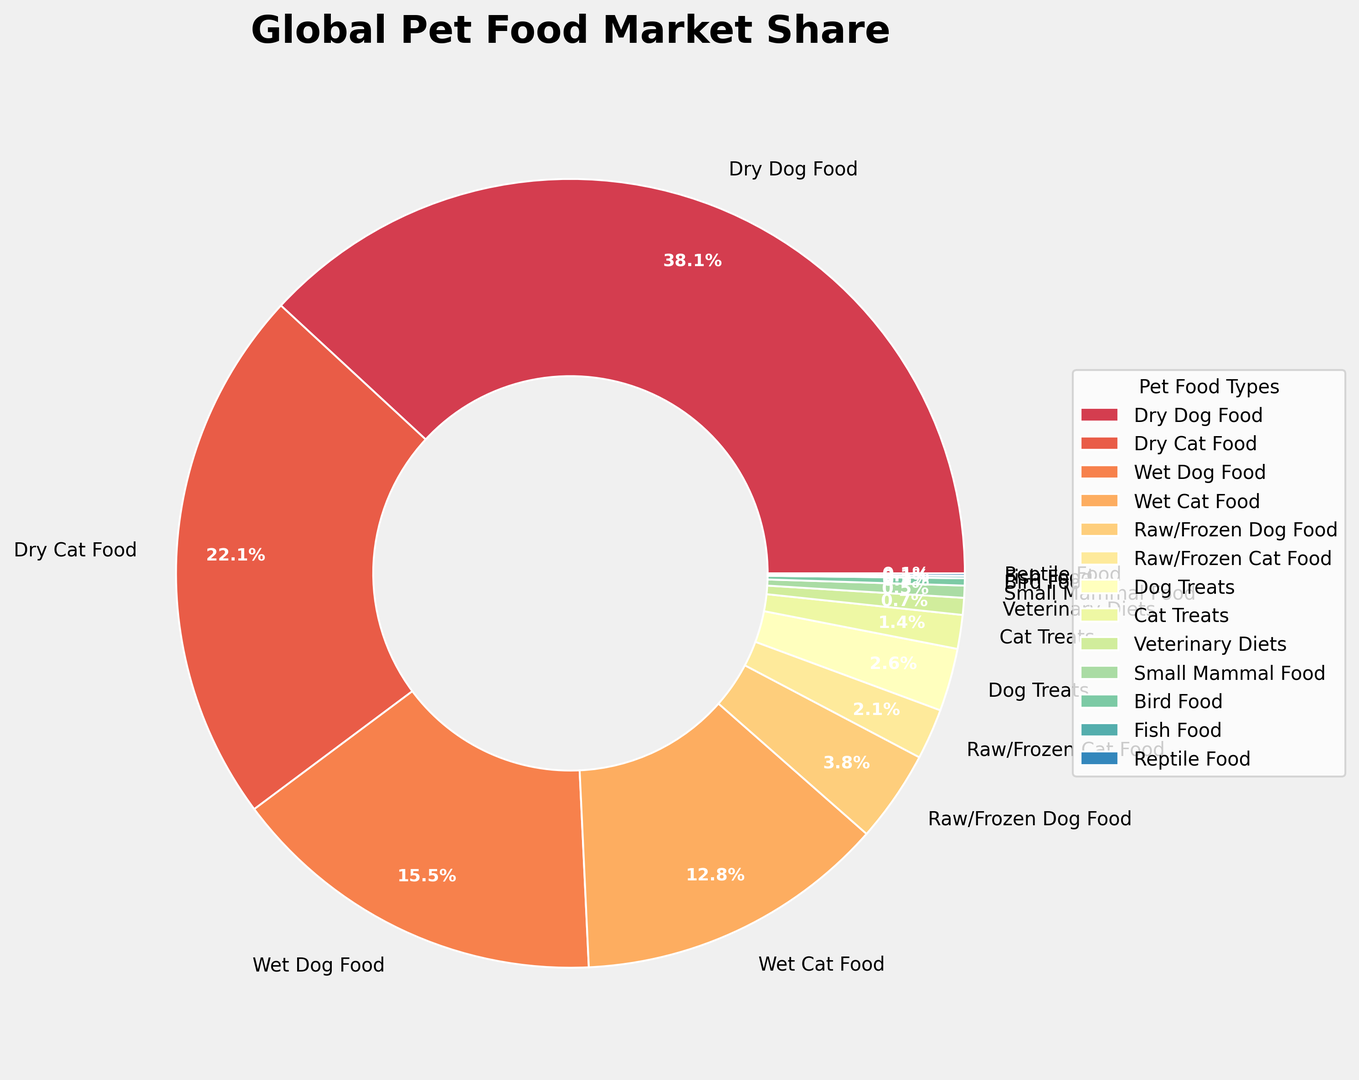What's the combined market share of all types of dry food? To find the combined market share of all types of dry food, add the market share of Dry Dog Food and Dry Cat Food: 38.5% + 22.3% = 60.8%
Answer: 60.8% Which type of pet food has the lowest market share, and what is that share? By examining the smallest section of the ring chart, we can see that Fish Food and Reptile Food both have the lowest market share, each with 0.1%.
Answer: Fish Food, Reptile Food, 0.1% Are there more market shares in the wet food category combined or the dry food category combined, and by how much? First, sum the market shares for wet food (Wet Dog Food + Wet Cat Food = 15.7% + 12.9% = 28.6%). Next, sum the market shares for dry food (Dry Dog Food + Dry Cat Food = 38.5% + 22.3% = 60.8%). Dry food market share is higher, and the difference is 60.8% - 28.6% = 32.2%.
Answer: Dry food by 32.2% What is the percentage difference between the market share of Dog Treats and Cat Treats? Subtract the market share of Cat Treats from Dog Treats and convert the result to a percentage: 2.6% - 1.4% = 1.2%.
Answer: 1.2% Which category has a larger market share, Raw/Frozen Dog Food or Raw/Frozen Cat Food, and by how much? By examining the chart, we see that Raw/Frozen Dog Food has a market share of 3.8%, and Raw/Frozen Cat Food has a market share of 2.1%. The difference is 3.8% - 2.1% = 1.7%.
Answer: Raw/Frozen Dog Food by 1.7% Which categories of pet food have a market share less than 1%, and what are they? Categories with a market share less than 1% are Veterinary Diets (0.7%), Small Mammal Food (0.5%), Bird Food (0.3%), Fish Food (0.1%), and Reptile Food (0.1%).
Answer: Veterinary Diets, Small Mammal Food, Bird Food, Fish Food, Reptile Food What is the share difference between the largest and smallest category in the chart? The largest market share is Dry Dog Food at 38.5% and the smallest market share is Fish Food and Reptile Food at 0.1%. The difference is 38.5% - 0.1% = 38.4%.
Answer: 38.4% How much larger is the combined market share of treats for dogs and cats than the market share of Veterinary Diets? First, sum the market shares of Dog Treats and Cat Treats: 2.6% + 1.4% = 4%. Then, subtract the market share of Veterinary Diets: 4% - 0.7% = 3.3%.
Answer: 3.3% Which has a greater market share, Wet Dog Food or Dry Cat Food, and by how much? By referencing the chart, Wet Dog Food has a market share of 15.7%, and Dry Cat Food has a market share of 22.3%, hence, Dry Cat Food is greater by 22.3% - 15.7% = 6.6%.
Answer: Dry Cat Food by 6.6% 